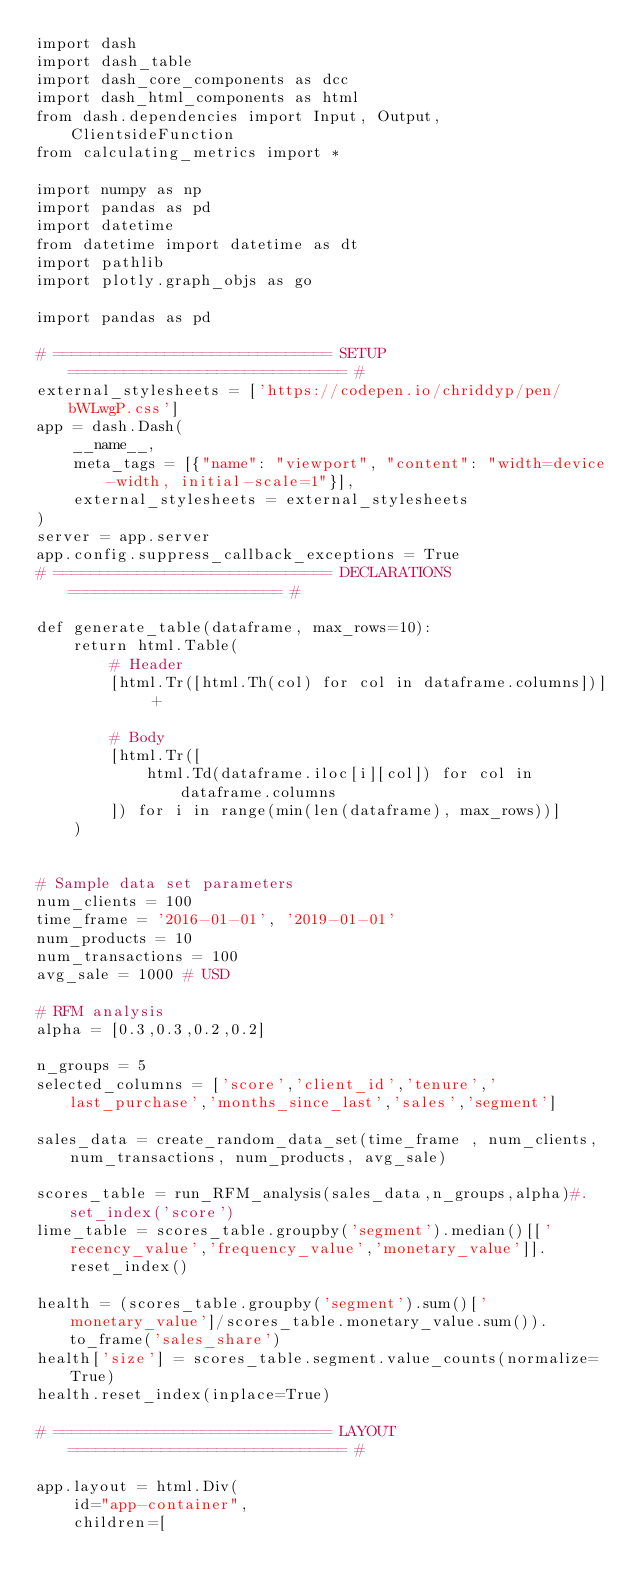Convert code to text. <code><loc_0><loc_0><loc_500><loc_500><_Python_>import dash
import dash_table
import dash_core_components as dcc
import dash_html_components as html
from dash.dependencies import Input, Output, ClientsideFunction
from calculating_metrics import *

import numpy as np
import pandas as pd
import datetime
from datetime import datetime as dt
import pathlib
import plotly.graph_objs as go

import pandas as pd

# ============================== SETUP ============================== #
external_stylesheets = ['https://codepen.io/chriddyp/pen/bWLwgP.css']
app = dash.Dash(
    __name__,
    meta_tags = [{"name": "viewport", "content": "width=device-width, initial-scale=1"}],
    external_stylesheets = external_stylesheets
)
server = app.server
app.config.suppress_callback_exceptions = True
# ============================== DECLARATIONS ======================= #

def generate_table(dataframe, max_rows=10):
    return html.Table(
        # Header
        [html.Tr([html.Th(col) for col in dataframe.columns])] +

        # Body
        [html.Tr([
            html.Td(dataframe.iloc[i][col]) for col in dataframe.columns
        ]) for i in range(min(len(dataframe), max_rows))]
    )


# Sample data set parameters
num_clients = 100
time_frame = '2016-01-01', '2019-01-01'
num_products = 10
num_transactions = 100
avg_sale = 1000 # USD

# RFM analysis
alpha = [0.3,0.3,0.2,0.2]

n_groups = 5
selected_columns = ['score','client_id','tenure','last_purchase','months_since_last','sales','segment']

sales_data = create_random_data_set(time_frame , num_clients, num_transactions, num_products, avg_sale)

scores_table = run_RFM_analysis(sales_data,n_groups,alpha)#.set_index('score')
lime_table = scores_table.groupby('segment').median()[['recency_value','frequency_value','monetary_value']].reset_index()

health = (scores_table.groupby('segment').sum()['monetary_value']/scores_table.monetary_value.sum()).to_frame('sales_share')
health['size'] = scores_table.segment.value_counts(normalize=True)
health.reset_index(inplace=True)

# ============================== LAYOUT ============================== #

app.layout = html.Div(
    id="app-container",
    children=[</code> 